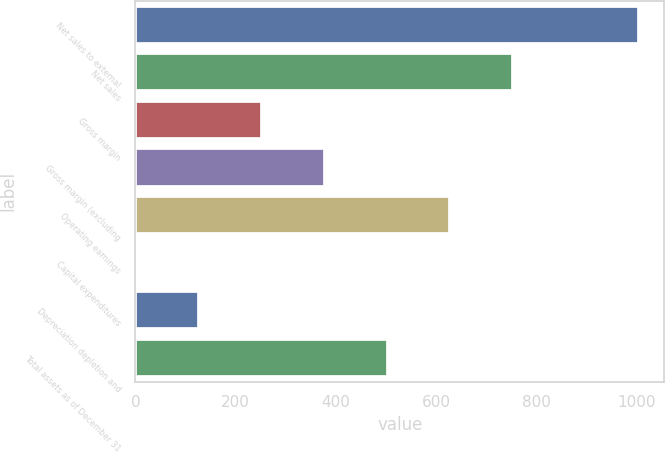<chart> <loc_0><loc_0><loc_500><loc_500><bar_chart><fcel>Net sales to external<fcel>Net sales<fcel>Gross margin<fcel>Gross margin (excluding<fcel>Operating earnings<fcel>Capital expenditures<fcel>Depreciation depletion and<fcel>Total assets as of December 31<nl><fcel>1003.9<fcel>753.4<fcel>252.4<fcel>377.65<fcel>628.15<fcel>1.9<fcel>127.15<fcel>502.9<nl></chart> 